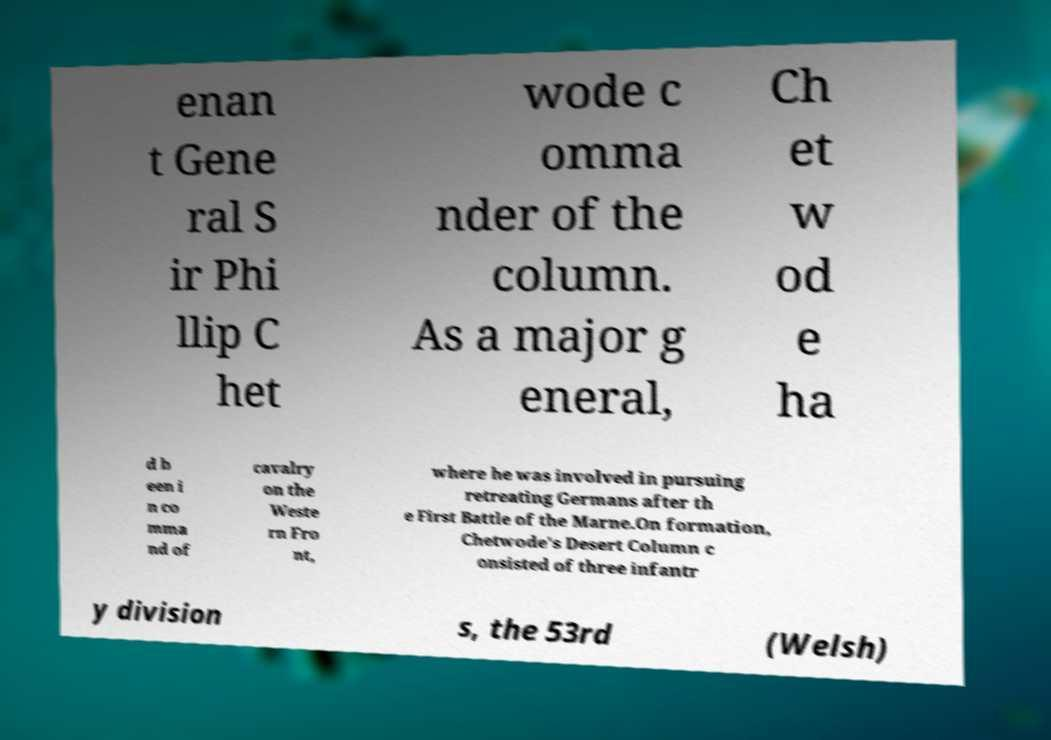Could you extract and type out the text from this image? enan t Gene ral S ir Phi llip C het wode c omma nder of the column. As a major g eneral, Ch et w od e ha d b een i n co mma nd of cavalry on the Weste rn Fro nt, where he was involved in pursuing retreating Germans after th e First Battle of the Marne.On formation, Chetwode's Desert Column c onsisted of three infantr y division s, the 53rd (Welsh) 